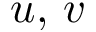<formula> <loc_0><loc_0><loc_500><loc_500>u , \, v</formula> 